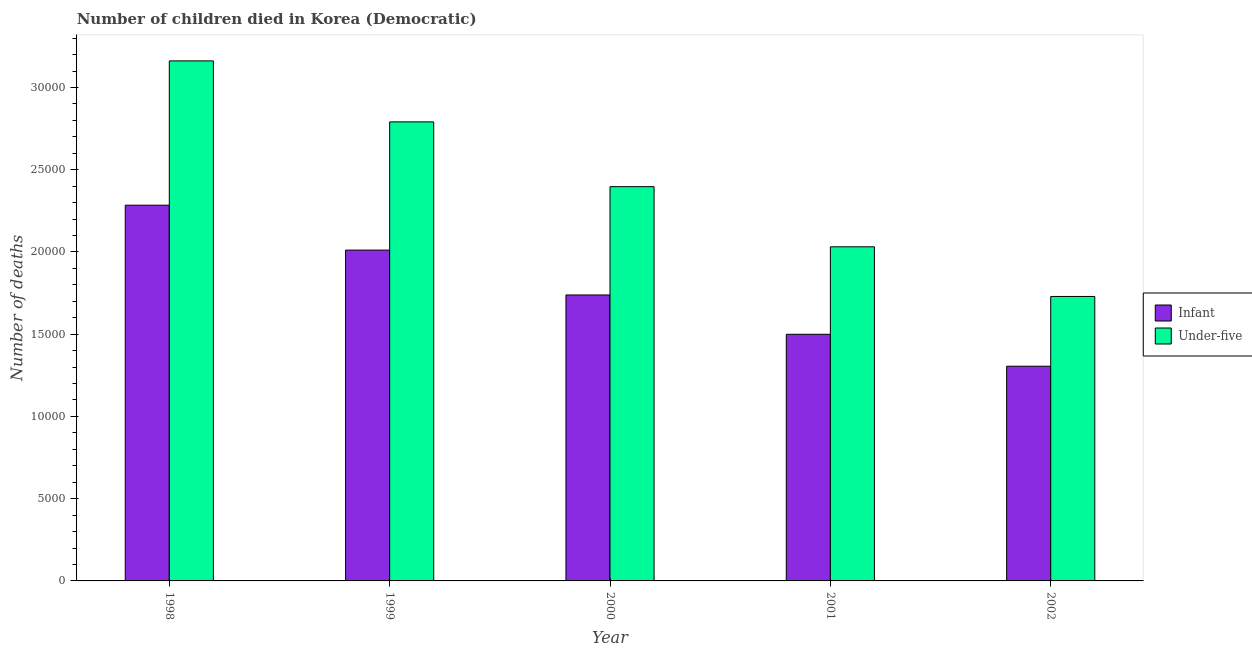How many bars are there on the 1st tick from the right?
Give a very brief answer. 2. In how many cases, is the number of bars for a given year not equal to the number of legend labels?
Offer a very short reply. 0. What is the number of under-five deaths in 2001?
Give a very brief answer. 2.03e+04. Across all years, what is the maximum number of under-five deaths?
Keep it short and to the point. 3.16e+04. Across all years, what is the minimum number of infant deaths?
Ensure brevity in your answer.  1.31e+04. What is the total number of infant deaths in the graph?
Your response must be concise. 8.84e+04. What is the difference between the number of infant deaths in 2000 and that in 2002?
Keep it short and to the point. 4332. What is the difference between the number of infant deaths in 2000 and the number of under-five deaths in 2001?
Make the answer very short. 2391. What is the average number of infant deaths per year?
Offer a terse response. 1.77e+04. In the year 1999, what is the difference between the number of under-five deaths and number of infant deaths?
Your answer should be very brief. 0. What is the ratio of the number of infant deaths in 2001 to that in 2002?
Keep it short and to the point. 1.15. Is the difference between the number of infant deaths in 1999 and 2002 greater than the difference between the number of under-five deaths in 1999 and 2002?
Your response must be concise. No. What is the difference between the highest and the second highest number of infant deaths?
Your answer should be compact. 2730. What is the difference between the highest and the lowest number of infant deaths?
Make the answer very short. 9790. What does the 2nd bar from the left in 2001 represents?
Offer a very short reply. Under-five. What does the 2nd bar from the right in 2001 represents?
Make the answer very short. Infant. Are all the bars in the graph horizontal?
Provide a succinct answer. No. Are the values on the major ticks of Y-axis written in scientific E-notation?
Your response must be concise. No. Does the graph contain grids?
Your response must be concise. No. How many legend labels are there?
Offer a very short reply. 2. What is the title of the graph?
Make the answer very short. Number of children died in Korea (Democratic). What is the label or title of the Y-axis?
Ensure brevity in your answer.  Number of deaths. What is the Number of deaths in Infant in 1998?
Provide a short and direct response. 2.28e+04. What is the Number of deaths in Under-five in 1998?
Make the answer very short. 3.16e+04. What is the Number of deaths of Infant in 1999?
Offer a terse response. 2.01e+04. What is the Number of deaths in Under-five in 1999?
Ensure brevity in your answer.  2.79e+04. What is the Number of deaths in Infant in 2000?
Your answer should be compact. 1.74e+04. What is the Number of deaths in Under-five in 2000?
Provide a short and direct response. 2.40e+04. What is the Number of deaths in Infant in 2001?
Your answer should be very brief. 1.50e+04. What is the Number of deaths of Under-five in 2001?
Offer a very short reply. 2.03e+04. What is the Number of deaths in Infant in 2002?
Ensure brevity in your answer.  1.31e+04. What is the Number of deaths in Under-five in 2002?
Your answer should be compact. 1.73e+04. Across all years, what is the maximum Number of deaths of Infant?
Offer a terse response. 2.28e+04. Across all years, what is the maximum Number of deaths in Under-five?
Your response must be concise. 3.16e+04. Across all years, what is the minimum Number of deaths in Infant?
Make the answer very short. 1.31e+04. Across all years, what is the minimum Number of deaths of Under-five?
Your answer should be very brief. 1.73e+04. What is the total Number of deaths in Infant in the graph?
Keep it short and to the point. 8.84e+04. What is the total Number of deaths in Under-five in the graph?
Keep it short and to the point. 1.21e+05. What is the difference between the Number of deaths of Infant in 1998 and that in 1999?
Provide a succinct answer. 2730. What is the difference between the Number of deaths in Under-five in 1998 and that in 1999?
Your response must be concise. 3709. What is the difference between the Number of deaths of Infant in 1998 and that in 2000?
Provide a short and direct response. 5458. What is the difference between the Number of deaths of Under-five in 1998 and that in 2000?
Provide a short and direct response. 7647. What is the difference between the Number of deaths of Infant in 1998 and that in 2001?
Your answer should be compact. 7849. What is the difference between the Number of deaths of Under-five in 1998 and that in 2001?
Your response must be concise. 1.13e+04. What is the difference between the Number of deaths of Infant in 1998 and that in 2002?
Your answer should be very brief. 9790. What is the difference between the Number of deaths of Under-five in 1998 and that in 2002?
Offer a very short reply. 1.43e+04. What is the difference between the Number of deaths of Infant in 1999 and that in 2000?
Give a very brief answer. 2728. What is the difference between the Number of deaths in Under-five in 1999 and that in 2000?
Provide a short and direct response. 3938. What is the difference between the Number of deaths of Infant in 1999 and that in 2001?
Provide a succinct answer. 5119. What is the difference between the Number of deaths of Under-five in 1999 and that in 2001?
Offer a very short reply. 7595. What is the difference between the Number of deaths of Infant in 1999 and that in 2002?
Provide a succinct answer. 7060. What is the difference between the Number of deaths in Under-five in 1999 and that in 2002?
Offer a very short reply. 1.06e+04. What is the difference between the Number of deaths in Infant in 2000 and that in 2001?
Provide a short and direct response. 2391. What is the difference between the Number of deaths of Under-five in 2000 and that in 2001?
Ensure brevity in your answer.  3657. What is the difference between the Number of deaths of Infant in 2000 and that in 2002?
Give a very brief answer. 4332. What is the difference between the Number of deaths of Under-five in 2000 and that in 2002?
Offer a very short reply. 6676. What is the difference between the Number of deaths of Infant in 2001 and that in 2002?
Provide a short and direct response. 1941. What is the difference between the Number of deaths of Under-five in 2001 and that in 2002?
Your answer should be compact. 3019. What is the difference between the Number of deaths in Infant in 1998 and the Number of deaths in Under-five in 1999?
Give a very brief answer. -5065. What is the difference between the Number of deaths of Infant in 1998 and the Number of deaths of Under-five in 2000?
Offer a terse response. -1127. What is the difference between the Number of deaths in Infant in 1998 and the Number of deaths in Under-five in 2001?
Provide a short and direct response. 2530. What is the difference between the Number of deaths in Infant in 1998 and the Number of deaths in Under-five in 2002?
Ensure brevity in your answer.  5549. What is the difference between the Number of deaths in Infant in 1999 and the Number of deaths in Under-five in 2000?
Keep it short and to the point. -3857. What is the difference between the Number of deaths in Infant in 1999 and the Number of deaths in Under-five in 2001?
Ensure brevity in your answer.  -200. What is the difference between the Number of deaths in Infant in 1999 and the Number of deaths in Under-five in 2002?
Offer a very short reply. 2819. What is the difference between the Number of deaths of Infant in 2000 and the Number of deaths of Under-five in 2001?
Your answer should be very brief. -2928. What is the difference between the Number of deaths of Infant in 2000 and the Number of deaths of Under-five in 2002?
Make the answer very short. 91. What is the difference between the Number of deaths of Infant in 2001 and the Number of deaths of Under-five in 2002?
Provide a short and direct response. -2300. What is the average Number of deaths of Infant per year?
Keep it short and to the point. 1.77e+04. What is the average Number of deaths of Under-five per year?
Make the answer very short. 2.42e+04. In the year 1998, what is the difference between the Number of deaths of Infant and Number of deaths of Under-five?
Offer a very short reply. -8774. In the year 1999, what is the difference between the Number of deaths of Infant and Number of deaths of Under-five?
Provide a succinct answer. -7795. In the year 2000, what is the difference between the Number of deaths in Infant and Number of deaths in Under-five?
Offer a very short reply. -6585. In the year 2001, what is the difference between the Number of deaths of Infant and Number of deaths of Under-five?
Provide a short and direct response. -5319. In the year 2002, what is the difference between the Number of deaths of Infant and Number of deaths of Under-five?
Make the answer very short. -4241. What is the ratio of the Number of deaths of Infant in 1998 to that in 1999?
Give a very brief answer. 1.14. What is the ratio of the Number of deaths in Under-five in 1998 to that in 1999?
Keep it short and to the point. 1.13. What is the ratio of the Number of deaths of Infant in 1998 to that in 2000?
Make the answer very short. 1.31. What is the ratio of the Number of deaths of Under-five in 1998 to that in 2000?
Offer a terse response. 1.32. What is the ratio of the Number of deaths in Infant in 1998 to that in 2001?
Offer a terse response. 1.52. What is the ratio of the Number of deaths in Under-five in 1998 to that in 2001?
Keep it short and to the point. 1.56. What is the ratio of the Number of deaths in Infant in 1998 to that in 2002?
Your answer should be compact. 1.75. What is the ratio of the Number of deaths of Under-five in 1998 to that in 2002?
Keep it short and to the point. 1.83. What is the ratio of the Number of deaths in Infant in 1999 to that in 2000?
Your answer should be very brief. 1.16. What is the ratio of the Number of deaths in Under-five in 1999 to that in 2000?
Offer a terse response. 1.16. What is the ratio of the Number of deaths of Infant in 1999 to that in 2001?
Keep it short and to the point. 1.34. What is the ratio of the Number of deaths in Under-five in 1999 to that in 2001?
Make the answer very short. 1.37. What is the ratio of the Number of deaths of Infant in 1999 to that in 2002?
Your response must be concise. 1.54. What is the ratio of the Number of deaths in Under-five in 1999 to that in 2002?
Offer a terse response. 1.61. What is the ratio of the Number of deaths in Infant in 2000 to that in 2001?
Provide a succinct answer. 1.16. What is the ratio of the Number of deaths in Under-five in 2000 to that in 2001?
Your answer should be compact. 1.18. What is the ratio of the Number of deaths in Infant in 2000 to that in 2002?
Provide a short and direct response. 1.33. What is the ratio of the Number of deaths of Under-five in 2000 to that in 2002?
Your answer should be compact. 1.39. What is the ratio of the Number of deaths in Infant in 2001 to that in 2002?
Give a very brief answer. 1.15. What is the ratio of the Number of deaths in Under-five in 2001 to that in 2002?
Keep it short and to the point. 1.17. What is the difference between the highest and the second highest Number of deaths in Infant?
Offer a terse response. 2730. What is the difference between the highest and the second highest Number of deaths in Under-five?
Provide a short and direct response. 3709. What is the difference between the highest and the lowest Number of deaths in Infant?
Offer a very short reply. 9790. What is the difference between the highest and the lowest Number of deaths in Under-five?
Your answer should be compact. 1.43e+04. 